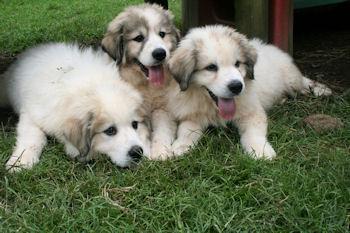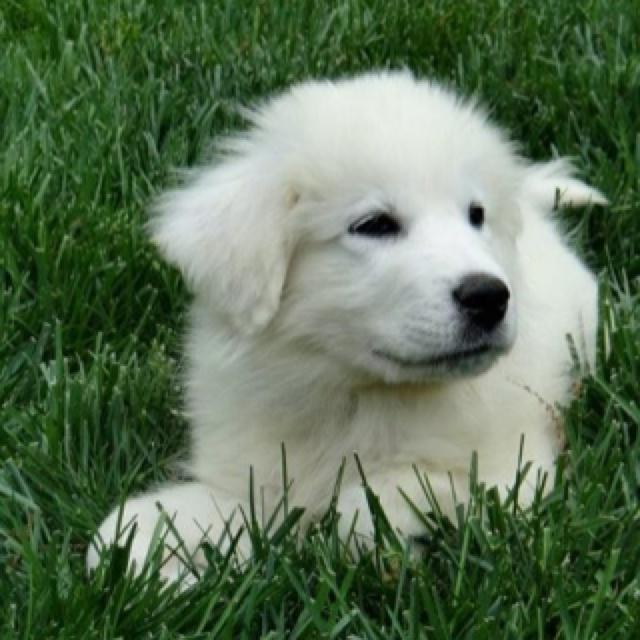The first image is the image on the left, the second image is the image on the right. Given the left and right images, does the statement "The combined images contain a total of four dogs, including a row of three dogs posed side-by-side." hold true? Answer yes or no. Yes. 